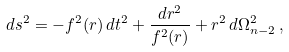<formula> <loc_0><loc_0><loc_500><loc_500>d s ^ { 2 } = - f ^ { 2 } ( r ) \, d t ^ { 2 } + \frac { d r ^ { 2 } } { f ^ { 2 } ( r ) } + r ^ { 2 } \, d \Omega ^ { 2 } _ { n - 2 } \, ,</formula> 